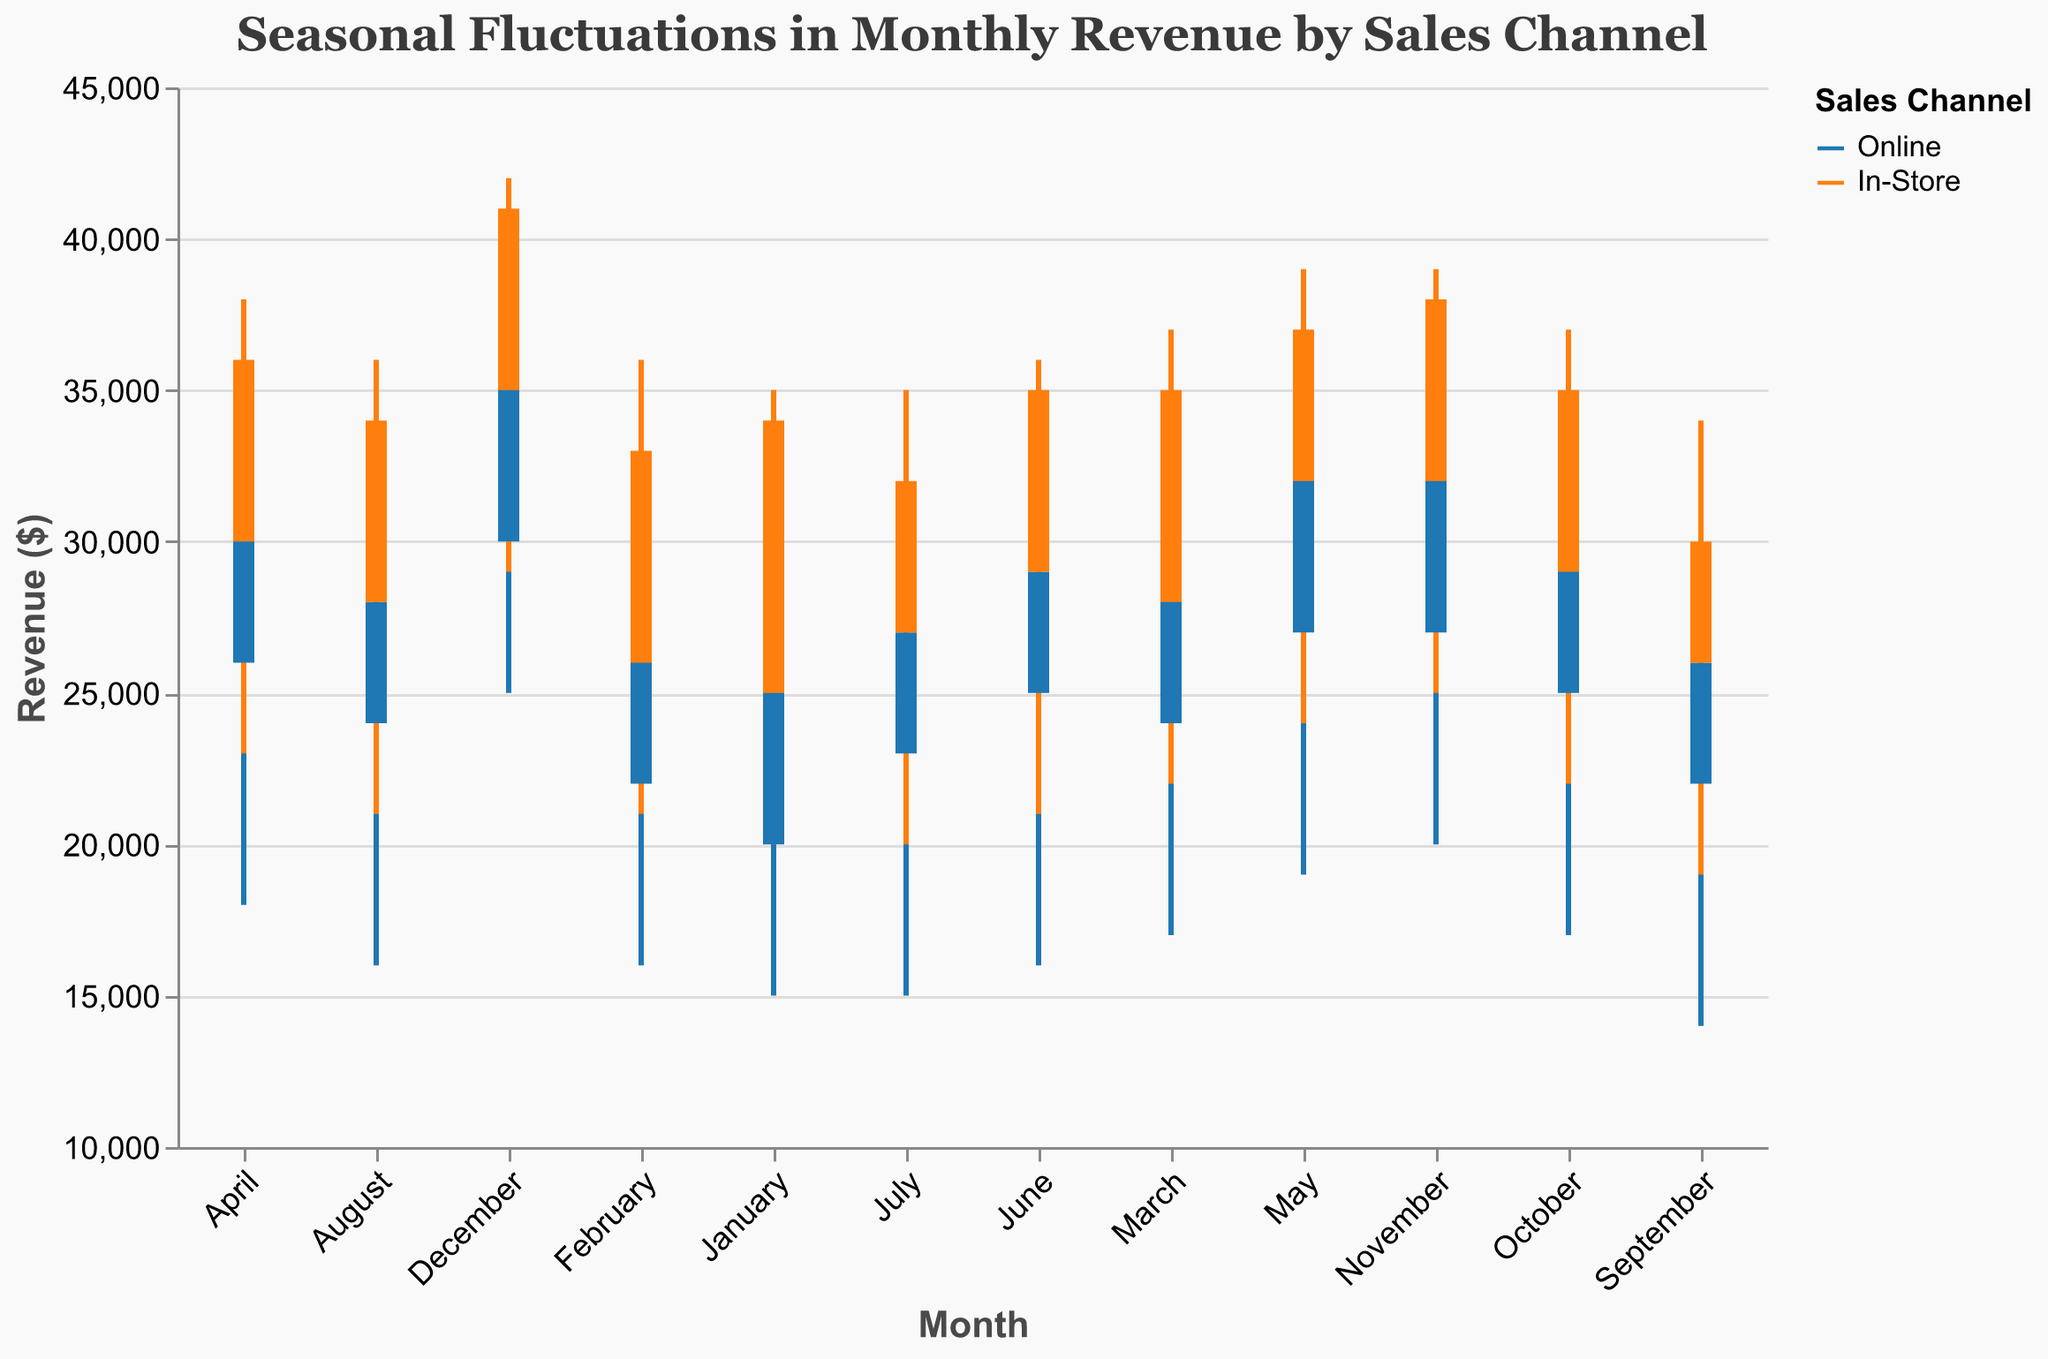What are the sales channels shown in the plot? The plot includes a color legend which shows the sales channels represented by different colors. There are two colors representing the two sales channels.
Answer: Online, In-Store Which month had the highest revenue for the In-Store sales channel? In-Store revenues can be identified by the color associated with that channel. By comparing the 'High' values across months, the highest value is identified.
Answer: December How does July's revenue in the Online channel compare to August's? Compare the 'Close' values of July and August in the Online sales channel. July's 'Close' value is 27000 and August's 'Close' value is 28000.
Answer: August's revenue is higher During which months did the Online sales channel show both its highest and lowest revenue points? Compare the 'High' and 'Low' values for the Online channel across all months to identify the maximum and minimum points.
Answer: December (highest) and September (lowest) What is the overall trend in revenue for the In-Store sales channel from January to December? Observe the 'Close' values for the In-Store channel. The trend can be seen by noting the revenue changes from month to month. The 'Close' values generally increase from January to December.
Answer: General upward trend What is the range of monthly revenue fluctuation in February for the Online channel? The range of revenue fluctuation can be determined by subtracting the 'Low' value from the 'High' value for February in the Online channel.
Answer: 15000 Which month saw the highest increase in revenue from the opening to the closing value for the In-Store sales channel? Calculate the difference between 'Close' and 'Open' values for the In-Store channel across all months, and identify the month with the highest difference.
Answer: February Which months saw a decrease in revenue from the opening to the closing value for the Online sales channel? Identify months where the 'Close' value is less than the 'Open' value for the Online channel.
Answer: June, July, September How does November's Online revenue 'High' value compare to December's 'Low' value? Compare the 'High' value of November with the 'Low' value of December for the Online channel. November's 'High' value is 35000 and December's 'Low' value is 25000.
Answer: November's 'High' value is higher Is the 'Open' value in April for the In-Store channel higher or lower than the 'Open' value in March for the same channel? Compare the 'Open' values in April and March for the In-Store channel. March's 'Open' is 28000 and April's 'Open' is 30000.
Answer: Higher in April 